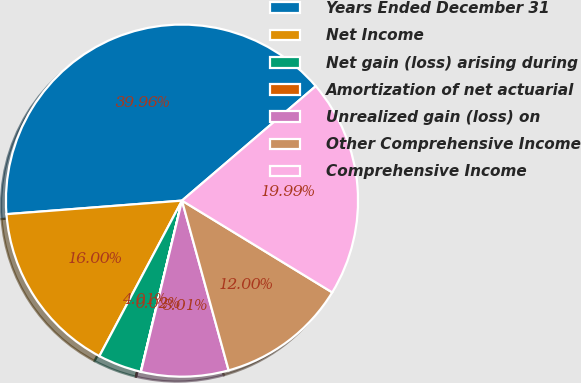Convert chart to OTSL. <chart><loc_0><loc_0><loc_500><loc_500><pie_chart><fcel>Years Ended December 31<fcel>Net Income<fcel>Net gain (loss) arising during<fcel>Amortization of net actuarial<fcel>Unrealized gain (loss) on<fcel>Other Comprehensive Income<fcel>Comprehensive Income<nl><fcel>39.96%<fcel>16.0%<fcel>4.01%<fcel>0.02%<fcel>8.01%<fcel>12.0%<fcel>19.99%<nl></chart> 